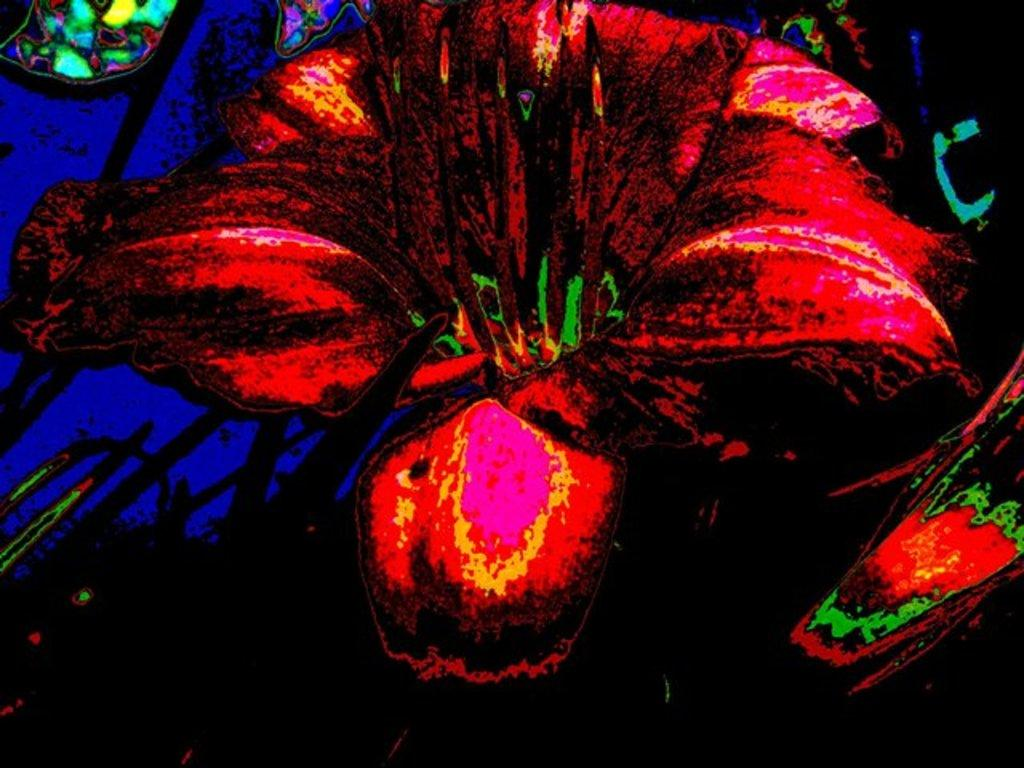What is the main subject of the image? The main subject of the image is a colorful design. Can you describe the design in more detail? The design resembles a flower. What type of artwork is the design? The design is a painting. What colors are present in the background of the image? The background of the image includes black and blue colors. What type of punishment is depicted in the painting? There is no punishment depicted in the painting; it features a colorful flower design. What time is shown on the clock in the image? There is no clock present in the image. 